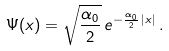<formula> <loc_0><loc_0><loc_500><loc_500>\Psi ( x ) = \sqrt { \frac { \alpha _ { 0 } } { 2 } } \, e ^ { - \frac { \alpha _ { 0 } } { 2 } \, | x | } \, .</formula> 